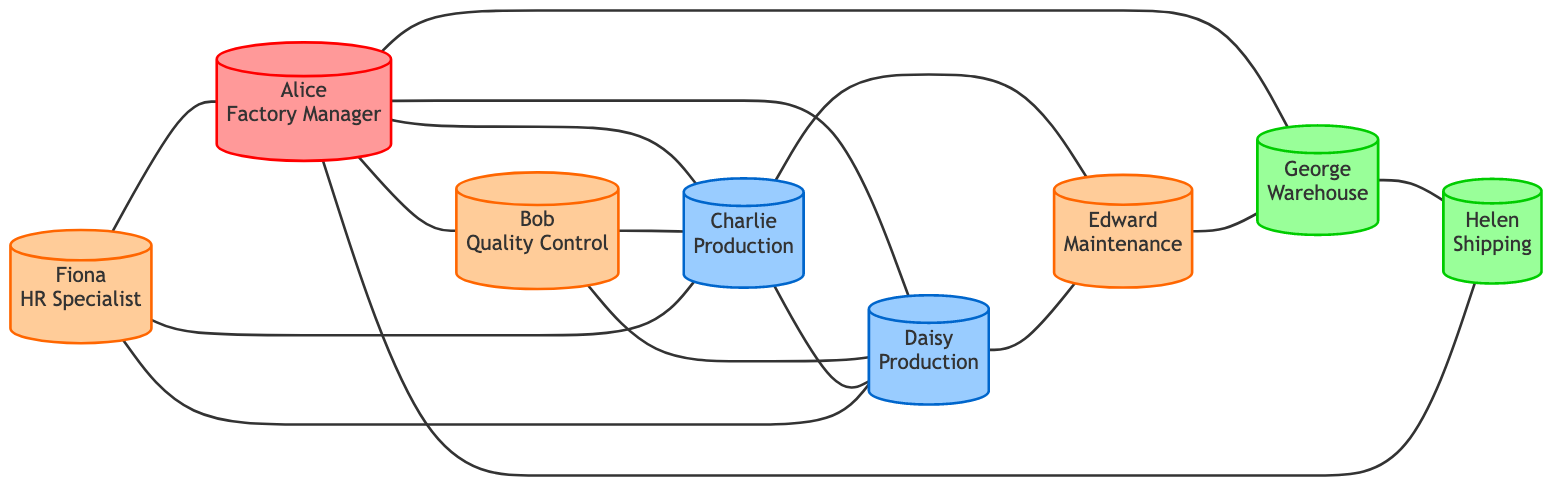What is the total number of nodes in the graph? The graph consists of eight individuals, each representing a different role in the manufacturing company, so the total number of nodes is counted as eight.
Answer: 8 Who manages the Quality Control Head? The diagram shows that Alice is designated as the Factory Manager, and there is a direct connection indicating that she manages Bob, who is the Quality Control Head.
Answer: Alice Which role requires maintenance? The diagram indicates that both Charlie and Daisy, who are labeled as Production Line Workers, have edges connecting them to Edward, the Maintenance Technician, indicating that they both require maintenance.
Answer: Production Line Worker How many employees report directly to the Factory Manager? By reviewing the connections from Alice (the Factory Manager), it can be observed that there are four individuals connected directly to her, indicating that four employees report to her.
Answer: 4 Identify the individual who coordinates with the Shipping Coordinator. The graph shows a connection from George, the Warehouse Supervisor, to Helen, the Shipping Coordinator, identifying that George coordinates with her.
Answer: George Who supports the Production Line Workers? The diagram indicates that Fiona, the HR Specialist, has edges connecting to both Charlie and Daisy, suggesting that she supports both Production Line Workers.
Answer: Fiona What is the relationship between the Warehouse Supervisor and the Shipping Coordinator? The edges show a connection where George (Warehouse Supervisor) coordinates with Helen (Shipping Coordinator), indicating their collaborative relationship.
Answer: coordinates with Which role links the Factory Manager and the Shipping Coordinator? The diagram reveals that there is a connection between Alice, the Factory Manager, and Helen, the Shipping Coordinator, through a direct link, showing that Helen reports to Alice.
Answer: reports to How many total relationships (edges) are represented in the graph? The graph displays multiple edges connecting the various nodes, and upon counting, there are a total of 12 edges representing different relationships among the employees.
Answer: 12 